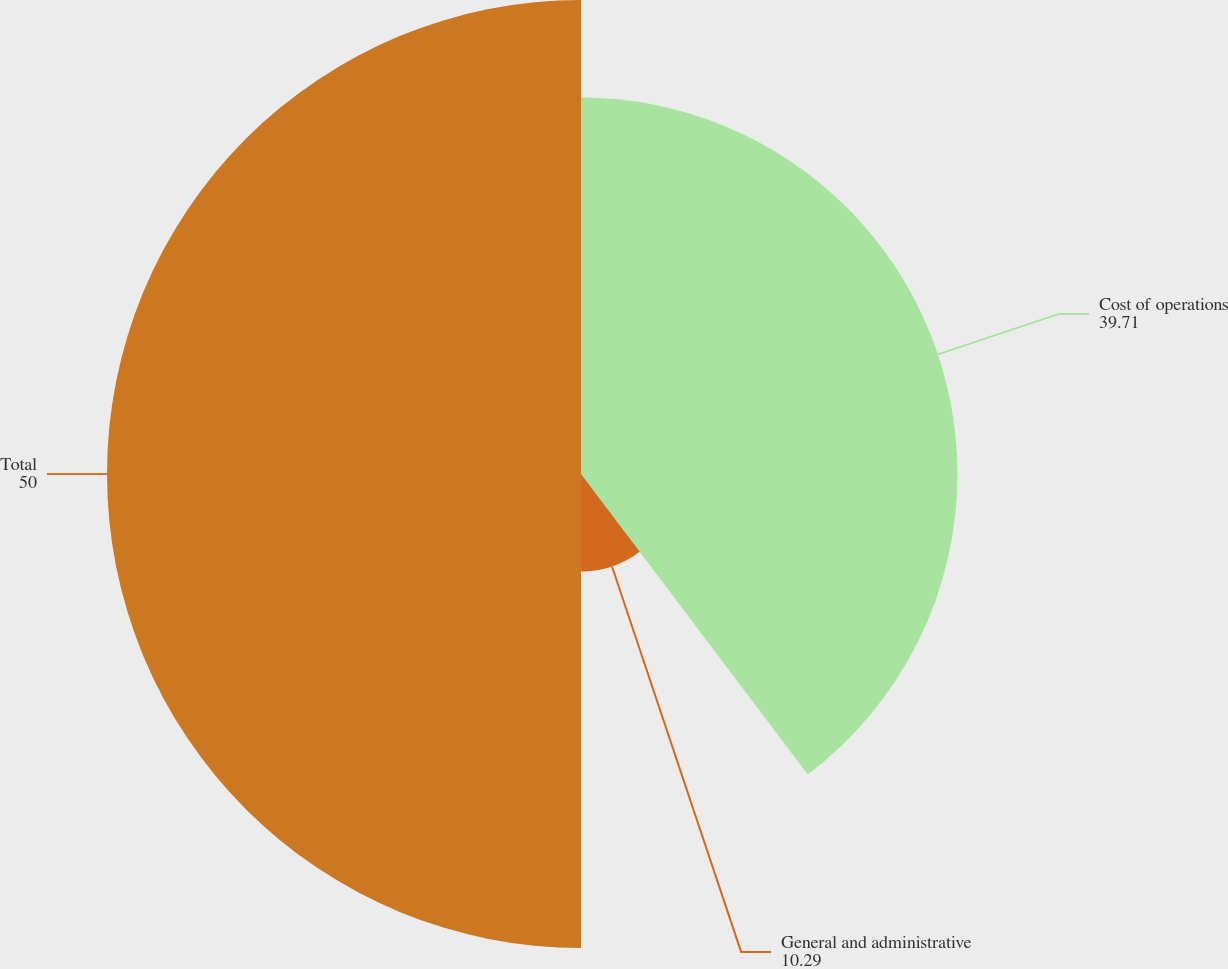Convert chart. <chart><loc_0><loc_0><loc_500><loc_500><pie_chart><fcel>Cost of operations<fcel>General and administrative<fcel>Total<nl><fcel>39.71%<fcel>10.29%<fcel>50.0%<nl></chart> 